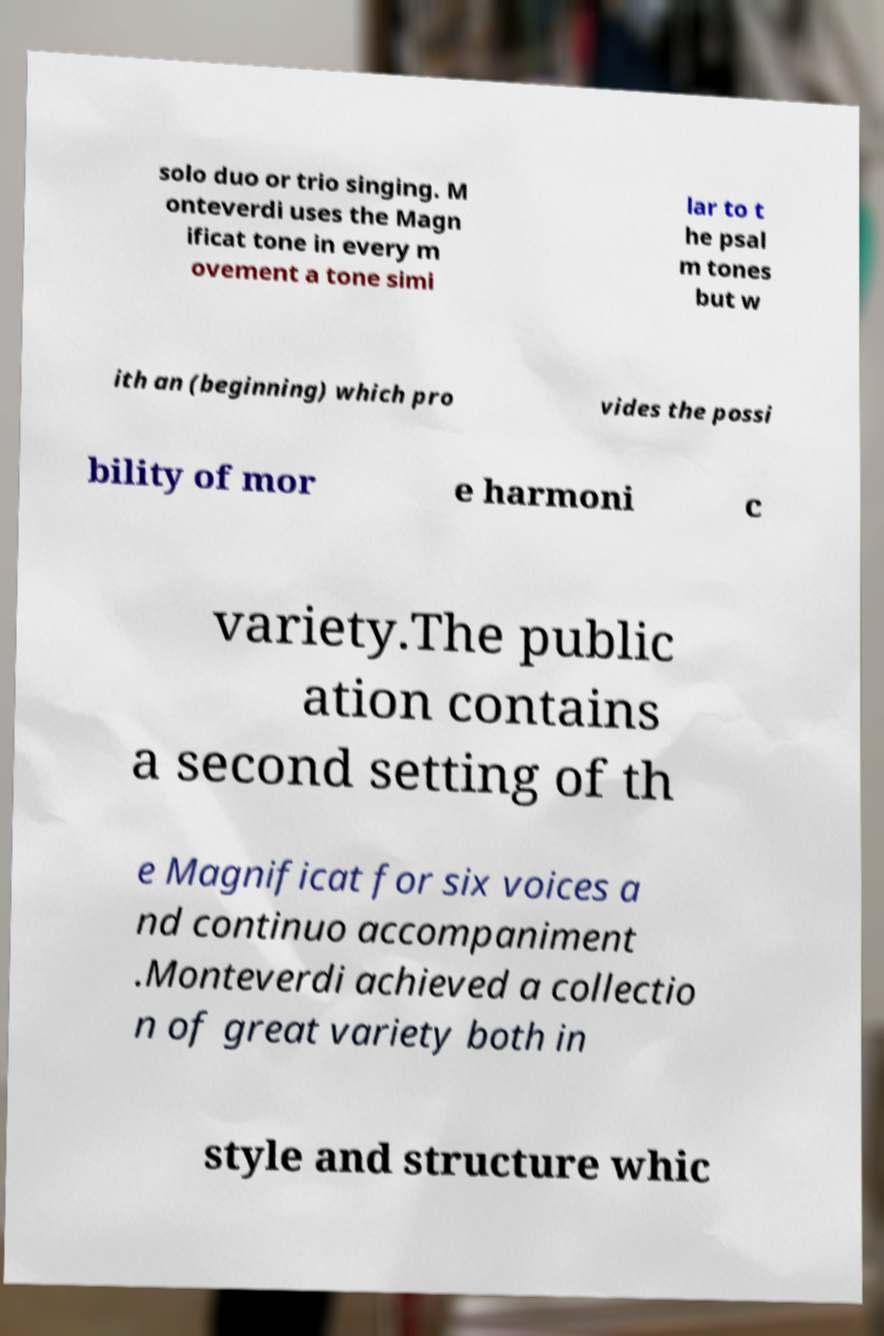Please read and relay the text visible in this image. What does it say? solo duo or trio singing. M onteverdi uses the Magn ificat tone in every m ovement a tone simi lar to t he psal m tones but w ith an (beginning) which pro vides the possi bility of mor e harmoni c variety.The public ation contains a second setting of th e Magnificat for six voices a nd continuo accompaniment .Monteverdi achieved a collectio n of great variety both in style and structure whic 